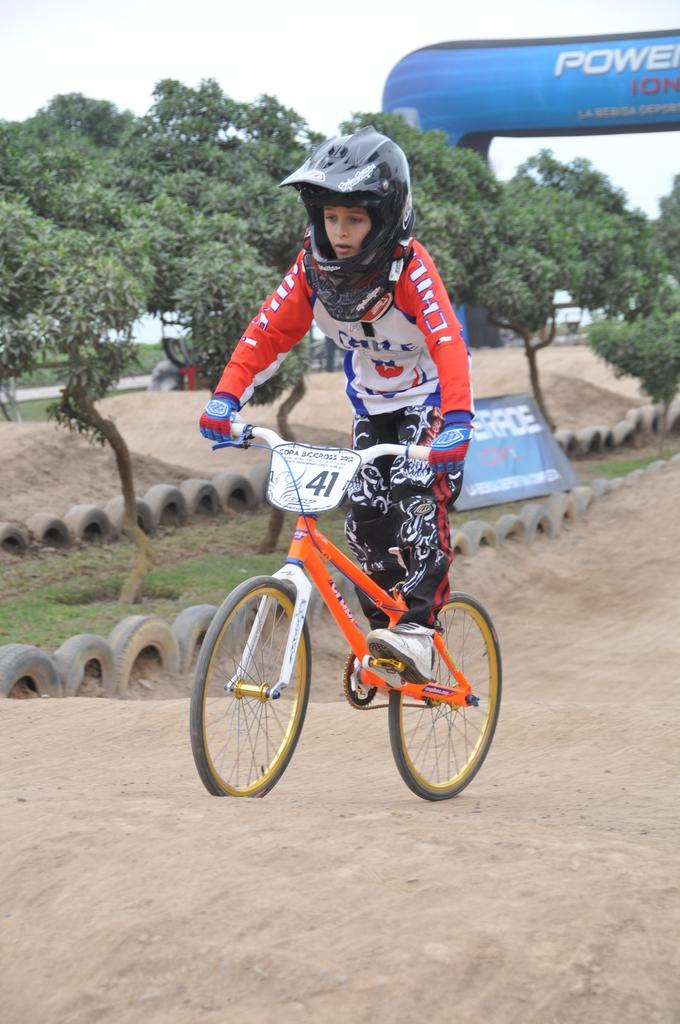What is the main subject in the foreground of the image? There is a boy riding a bicycle in the foreground of the image. What safety precaution is the boy taking while riding the bicycle? The boy is wearing a helmet. What can be seen in the background of the image besides the trees and sky? There are tyres, a banner, and an inflatable object in the background of the image. What type of joke is the boy telling while riding the bicycle? There is no indication in the image that the boy is telling a joke while riding the bicycle. Is the boy wearing a glove while riding the bicycle? The image does not show the boy wearing a glove; he is only wearing a helmet. 